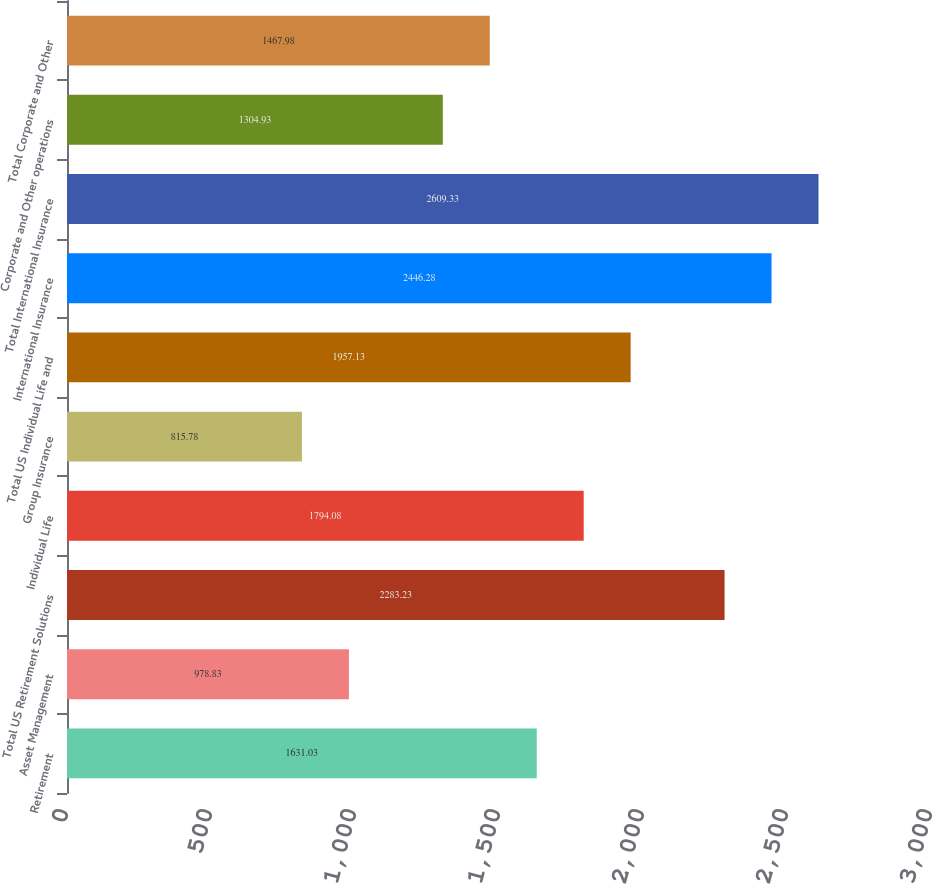Convert chart. <chart><loc_0><loc_0><loc_500><loc_500><bar_chart><fcel>Retirement<fcel>Asset Management<fcel>Total US Retirement Solutions<fcel>Individual Life<fcel>Group Insurance<fcel>Total US Individual Life and<fcel>International Insurance<fcel>Total International Insurance<fcel>Corporate and Other operations<fcel>Total Corporate and Other<nl><fcel>1631.03<fcel>978.83<fcel>2283.23<fcel>1794.08<fcel>815.78<fcel>1957.13<fcel>2446.28<fcel>2609.33<fcel>1304.93<fcel>1467.98<nl></chart> 